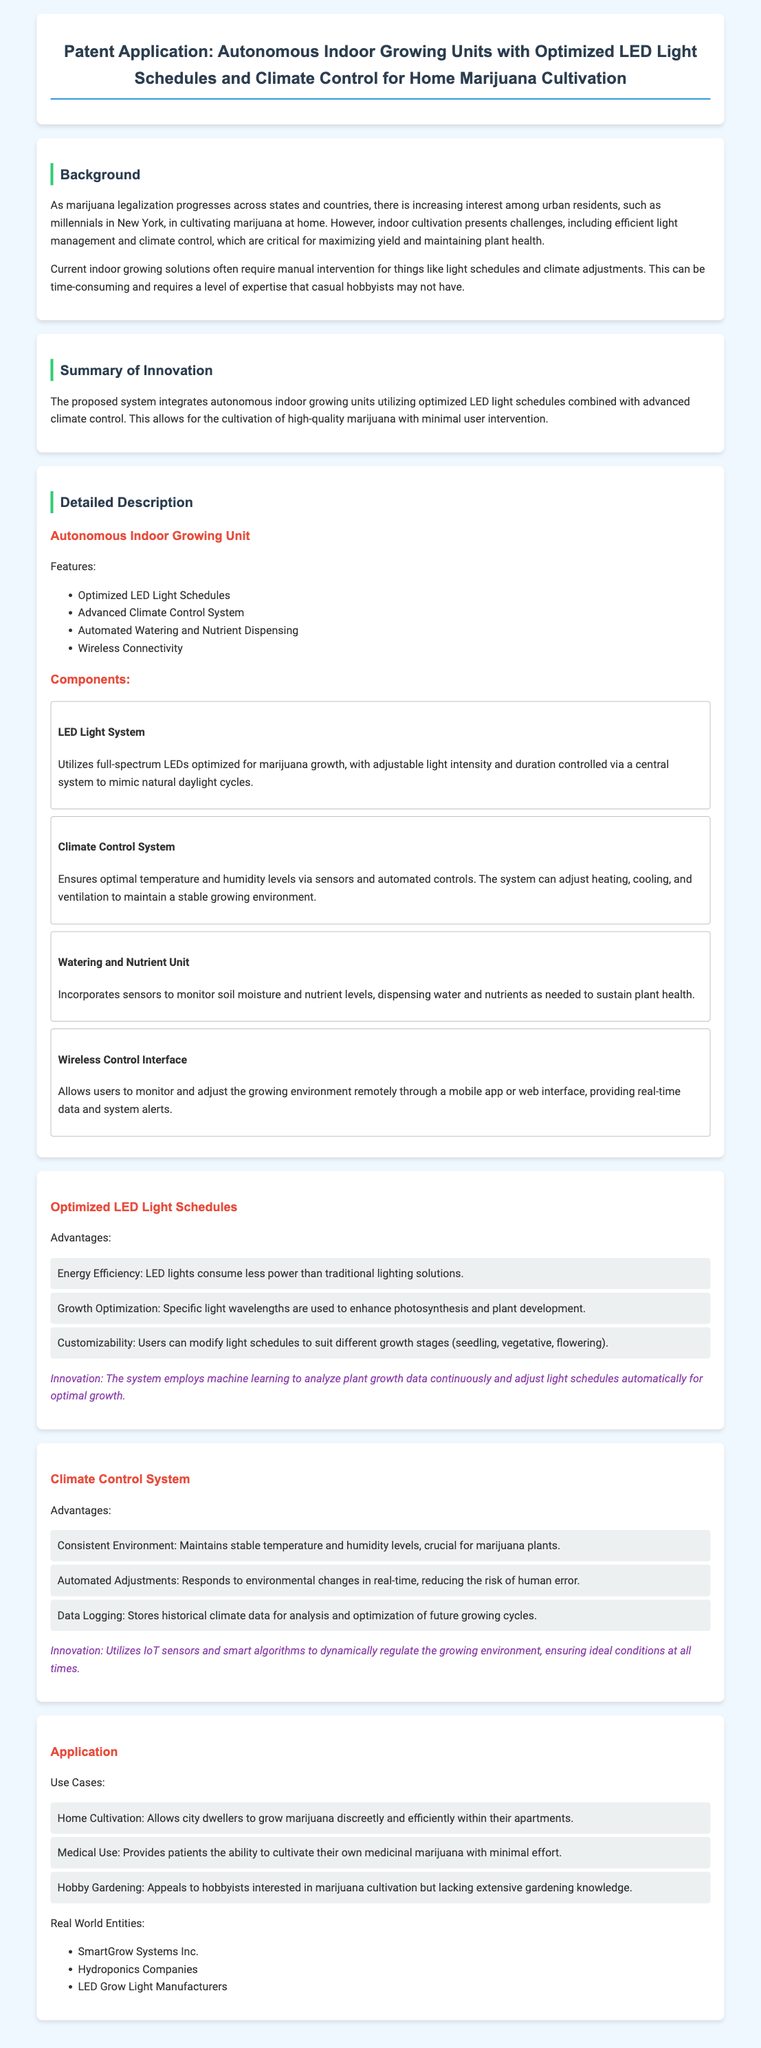What is the main purpose of the patent? The purpose is to describe a system for autonomous indoor growing units designed for home marijuana cultivation.
Answer: Autonomous indoor growing units What feature allows users to monitor the growing environment remotely? The feature that enables remote monitoring is the interface through a mobile app or web.
Answer: Wireless Control Interface How many components are listed under the detailed description? The number of components listed in the detailed description is four.
Answer: Four What is one advantage of the LED light system? An advantage is energy efficiency, as LED lights consume less power than traditional lighting solutions.
Answer: Energy Efficiency What is the application for medical use referred to in the document? The application for medical use allows patients to cultivate their own medicinal marijuana.
Answer: Cultivate their own medicinal marijuana How does the climate control system maintain a consistent environment? It maintains consistency through automated adjustments responding to environmental changes.
Answer: Automated Adjustments What type of technology does the system employ for light schedule optimization? The system employs machine learning to analyze plant growth data.
Answer: Machine learning What entities are mentioned as real-world applications of this technology? The document mentions SmartGrow Systems Inc., Hydroponics Companies, and LED Grow Light Manufacturers.
Answer: SmartGrow Systems Inc., Hydroponics Companies, and LED Grow Light Manufacturers 